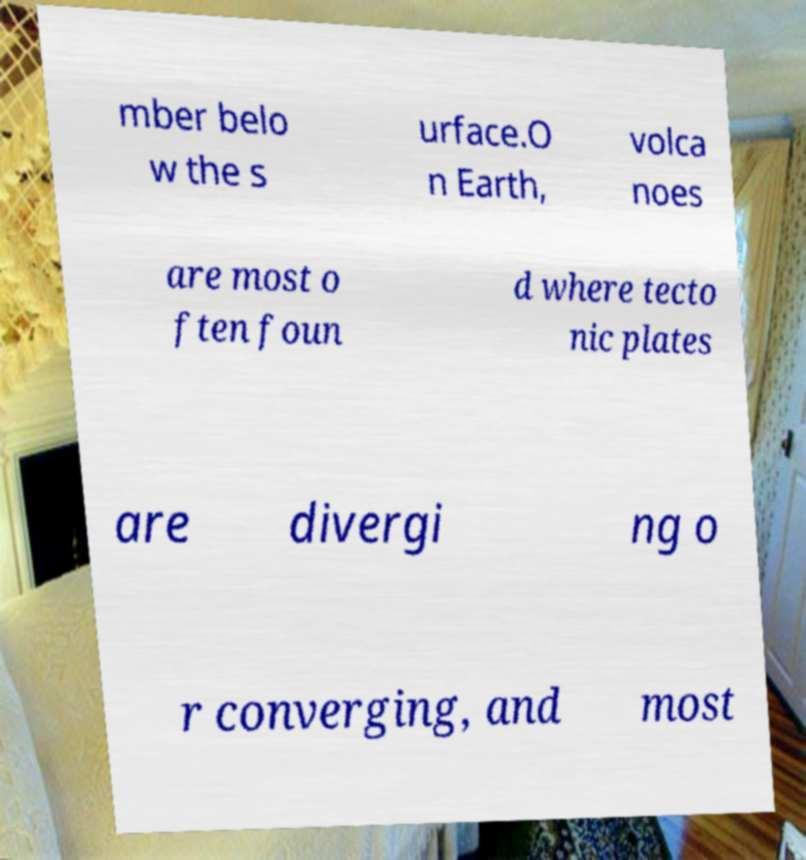Can you accurately transcribe the text from the provided image for me? mber belo w the s urface.O n Earth, volca noes are most o ften foun d where tecto nic plates are divergi ng o r converging, and most 